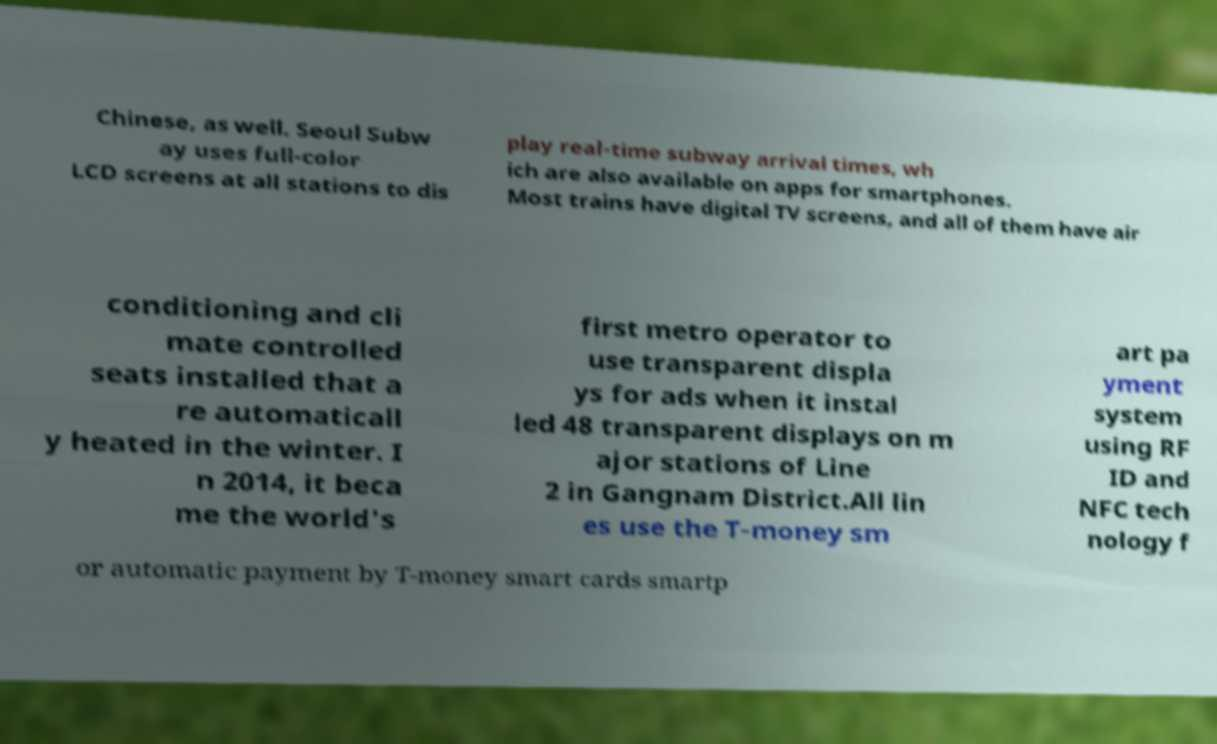Please identify and transcribe the text found in this image. Chinese, as well. Seoul Subw ay uses full-color LCD screens at all stations to dis play real-time subway arrival times, wh ich are also available on apps for smartphones. Most trains have digital TV screens, and all of them have air conditioning and cli mate controlled seats installed that a re automaticall y heated in the winter. I n 2014, it beca me the world's first metro operator to use transparent displa ys for ads when it instal led 48 transparent displays on m ajor stations of Line 2 in Gangnam District.All lin es use the T-money sm art pa yment system using RF ID and NFC tech nology f or automatic payment by T-money smart cards smartp 